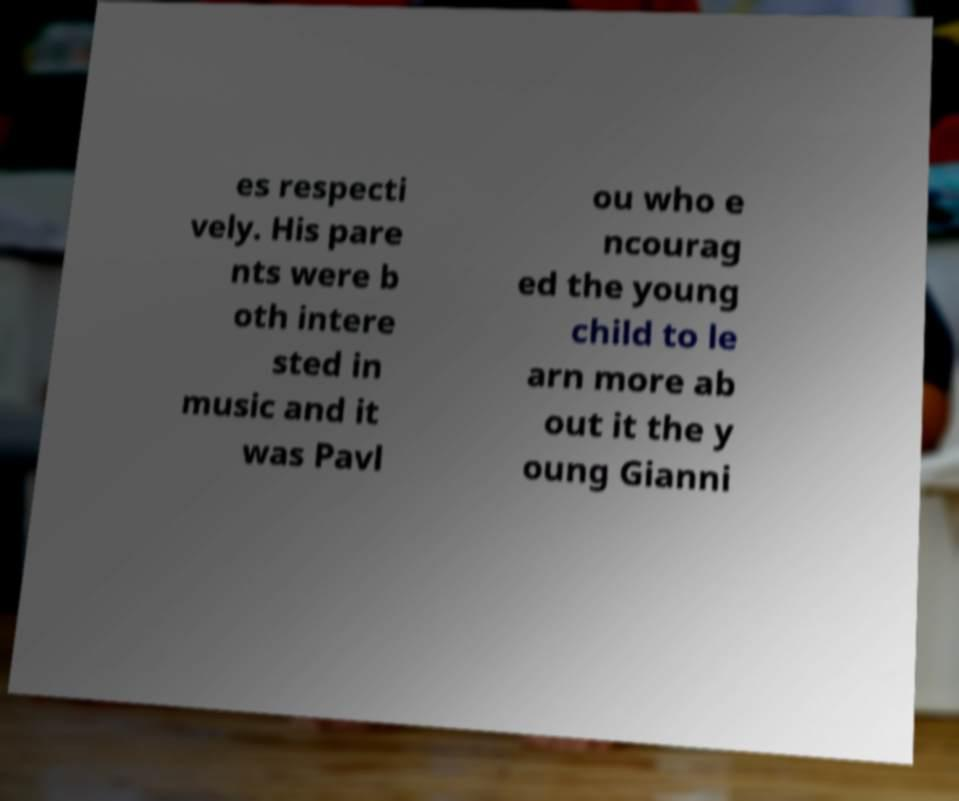Can you accurately transcribe the text from the provided image for me? es respecti vely. His pare nts were b oth intere sted in music and it was Pavl ou who e ncourag ed the young child to le arn more ab out it the y oung Gianni 